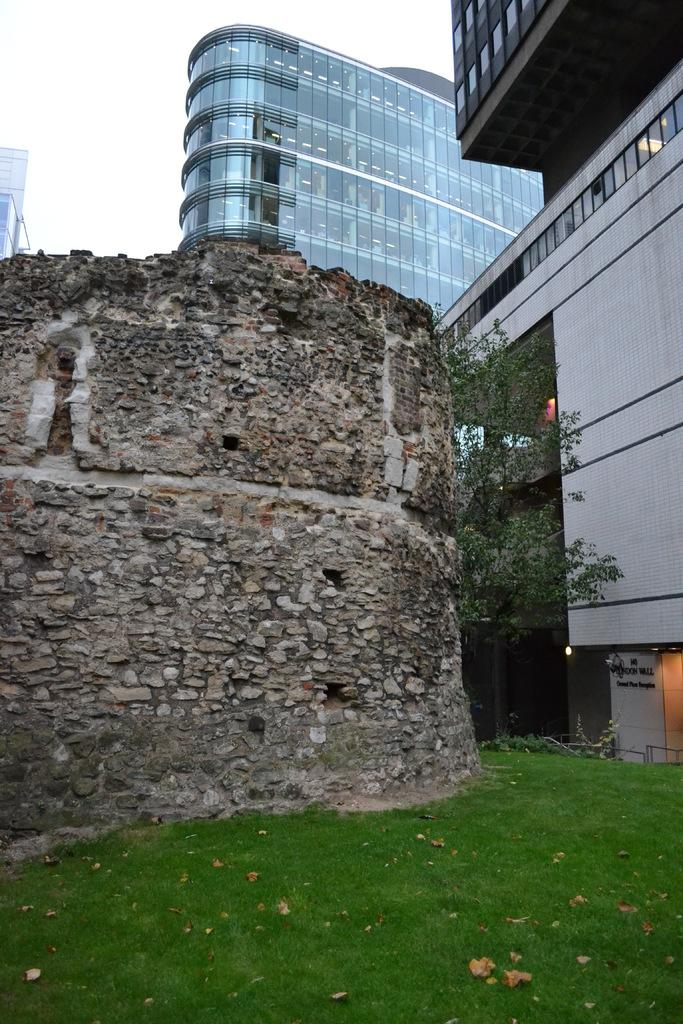What type of landscape is depicted in the image? There is a grassland in the image. What can be seen in the background of the image? There is a wall, buildings, and a tree in the background of the image. Where is the giraffe sitting in the image? There is no giraffe present in the image. What type of cloth is draped over the tree in the image? There is no cloth draped over the tree in the image. 